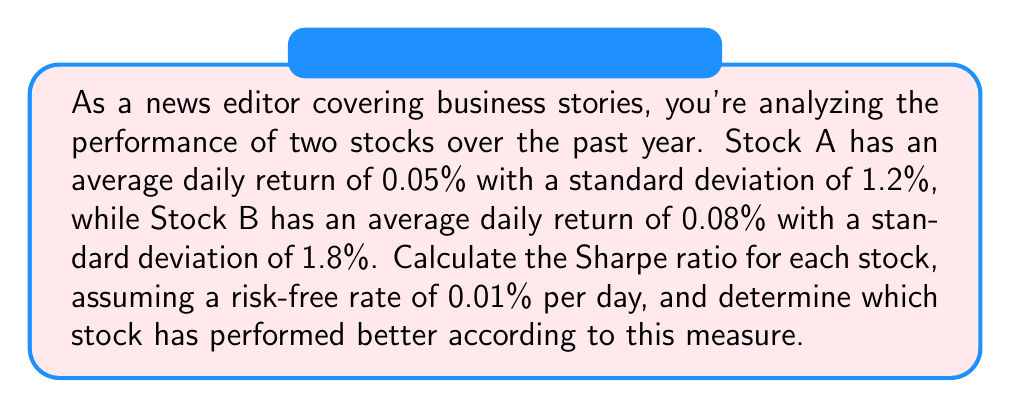Show me your answer to this math problem. To evaluate stock performance using the Sharpe ratio, we'll follow these steps:

1. The Sharpe ratio is calculated using the formula:

   $$ \text{Sharpe Ratio} = \frac{R_p - R_f}{\sigma_p} $$

   Where:
   $R_p$ = Average daily return of the stock
   $R_f$ = Risk-free rate
   $\sigma_p$ = Standard deviation of the stock's daily returns

2. For Stock A:
   $R_p = 0.05\%$
   $R_f = 0.01\%$
   $\sigma_p = 1.2\%$

   Sharpe Ratio for Stock A:
   $$ \text{Sharpe Ratio}_A = \frac{0.05\% - 0.01\%}{1.2\%} = \frac{0.04\%}{1.2\%} = 0.0333 $$

3. For Stock B:
   $R_p = 0.08\%$
   $R_f = 0.01\%$
   $\sigma_p = 1.8\%$

   Sharpe Ratio for Stock B:
   $$ \text{Sharpe Ratio}_B = \frac{0.08\% - 0.01\%}{1.8\%} = \frac{0.07\%}{1.8\%} = 0.0389 $$

4. Comparing the Sharpe ratios:
   Stock A: 0.0333
   Stock B: 0.0389

   A higher Sharpe ratio indicates better risk-adjusted performance. Therefore, Stock B has performed better according to this measure.
Answer: Stock B has performed better with a Sharpe ratio of 0.0389, compared to Stock A's Sharpe ratio of 0.0333. 